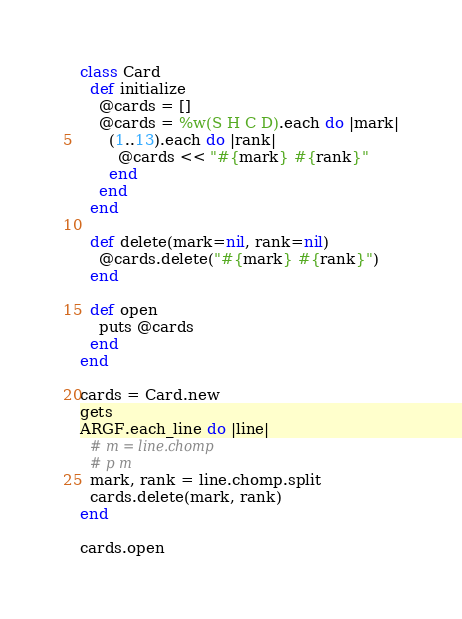Convert code to text. <code><loc_0><loc_0><loc_500><loc_500><_Ruby_>class Card
  def initialize
    @cards = []
    @cards = %w(S H C D).each do |mark|
      (1..13).each do |rank|
        @cards << "#{mark} #{rank}"
      end
    end
  end

  def delete(mark=nil, rank=nil)
    @cards.delete("#{mark} #{rank}")
  end

  def open
    puts @cards
  end
end

cards = Card.new
gets
ARGF.each_line do |line|
  # m = line.chomp
  # p m
  mark, rank = line.chomp.split
  cards.delete(mark, rank)
end

cards.open</code> 